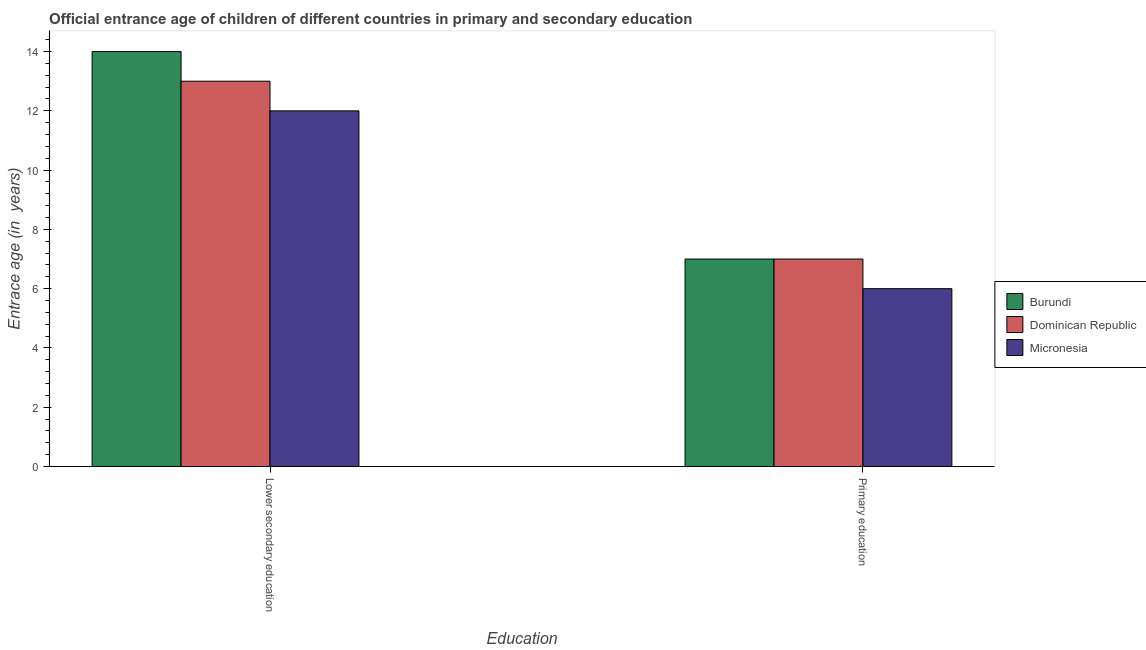How many different coloured bars are there?
Give a very brief answer. 3. Are the number of bars on each tick of the X-axis equal?
Provide a succinct answer. Yes. How many bars are there on the 2nd tick from the left?
Provide a succinct answer. 3. How many bars are there on the 1st tick from the right?
Make the answer very short. 3. What is the label of the 2nd group of bars from the left?
Provide a succinct answer. Primary education. What is the entrance age of chiildren in primary education in Burundi?
Your answer should be very brief. 7. Across all countries, what is the maximum entrance age of chiildren in primary education?
Your response must be concise. 7. Across all countries, what is the minimum entrance age of children in lower secondary education?
Provide a short and direct response. 12. In which country was the entrance age of children in lower secondary education maximum?
Offer a terse response. Burundi. In which country was the entrance age of chiildren in primary education minimum?
Provide a short and direct response. Micronesia. What is the total entrance age of chiildren in primary education in the graph?
Make the answer very short. 20. What is the difference between the entrance age of children in lower secondary education in Burundi and that in Micronesia?
Provide a succinct answer. 2. What is the difference between the entrance age of chiildren in primary education in Dominican Republic and the entrance age of children in lower secondary education in Burundi?
Your response must be concise. -7. What is the average entrance age of chiildren in primary education per country?
Keep it short and to the point. 6.67. What is the difference between the entrance age of chiildren in primary education and entrance age of children in lower secondary education in Burundi?
Give a very brief answer. -7. In how many countries, is the entrance age of chiildren in primary education greater than 7.6 years?
Your response must be concise. 0. What is the ratio of the entrance age of chiildren in primary education in Micronesia to that in Dominican Republic?
Offer a very short reply. 0.86. Is the entrance age of chiildren in primary education in Burundi less than that in Dominican Republic?
Your answer should be compact. No. What does the 3rd bar from the left in Lower secondary education represents?
Your answer should be compact. Micronesia. What does the 3rd bar from the right in Primary education represents?
Your answer should be very brief. Burundi. How many bars are there?
Make the answer very short. 6. Are all the bars in the graph horizontal?
Your response must be concise. No. What is the difference between two consecutive major ticks on the Y-axis?
Your answer should be very brief. 2. Are the values on the major ticks of Y-axis written in scientific E-notation?
Your answer should be compact. No. Does the graph contain any zero values?
Provide a short and direct response. No. Does the graph contain grids?
Give a very brief answer. No. How many legend labels are there?
Your answer should be compact. 3. What is the title of the graph?
Provide a short and direct response. Official entrance age of children of different countries in primary and secondary education. Does "Luxembourg" appear as one of the legend labels in the graph?
Give a very brief answer. No. What is the label or title of the X-axis?
Your response must be concise. Education. What is the label or title of the Y-axis?
Give a very brief answer. Entrace age (in  years). What is the Entrace age (in  years) in Dominican Republic in Lower secondary education?
Provide a short and direct response. 13. Across all Education, what is the maximum Entrace age (in  years) of Burundi?
Your answer should be very brief. 14. Across all Education, what is the maximum Entrace age (in  years) of Micronesia?
Make the answer very short. 12. Across all Education, what is the minimum Entrace age (in  years) in Dominican Republic?
Keep it short and to the point. 7. Across all Education, what is the minimum Entrace age (in  years) in Micronesia?
Make the answer very short. 6. What is the difference between the Entrace age (in  years) in Dominican Republic in Lower secondary education and that in Primary education?
Give a very brief answer. 6. What is the average Entrace age (in  years) in Burundi per Education?
Offer a terse response. 10.5. What is the difference between the Entrace age (in  years) in Burundi and Entrace age (in  years) in Micronesia in Lower secondary education?
Your answer should be very brief. 2. What is the difference between the Entrace age (in  years) in Burundi and Entrace age (in  years) in Micronesia in Primary education?
Provide a short and direct response. 1. What is the ratio of the Entrace age (in  years) of Burundi in Lower secondary education to that in Primary education?
Provide a succinct answer. 2. What is the ratio of the Entrace age (in  years) of Dominican Republic in Lower secondary education to that in Primary education?
Offer a terse response. 1.86. What is the difference between the highest and the second highest Entrace age (in  years) of Dominican Republic?
Your response must be concise. 6. What is the difference between the highest and the second highest Entrace age (in  years) of Micronesia?
Make the answer very short. 6. What is the difference between the highest and the lowest Entrace age (in  years) in Burundi?
Offer a terse response. 7. 